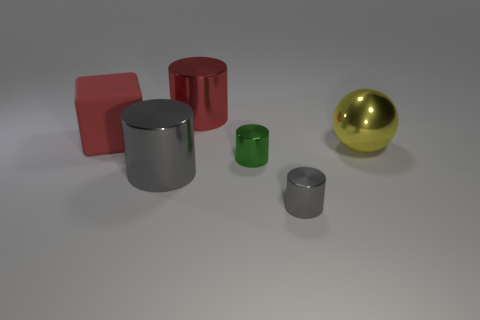Add 1 tiny cyan cylinders. How many objects exist? 7 Subtract all cyan spheres. How many gray cylinders are left? 2 Subtract all red cylinders. How many cylinders are left? 3 Subtract all cylinders. How many objects are left? 2 Subtract 3 cylinders. How many cylinders are left? 1 Add 2 purple cubes. How many purple cubes exist? 2 Subtract all green cylinders. How many cylinders are left? 3 Subtract 0 cyan blocks. How many objects are left? 6 Subtract all green cylinders. Subtract all cyan blocks. How many cylinders are left? 3 Subtract all tiny shiny spheres. Subtract all cylinders. How many objects are left? 2 